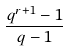<formula> <loc_0><loc_0><loc_500><loc_500>\frac { q ^ { r + 1 } - 1 } { q - 1 }</formula> 